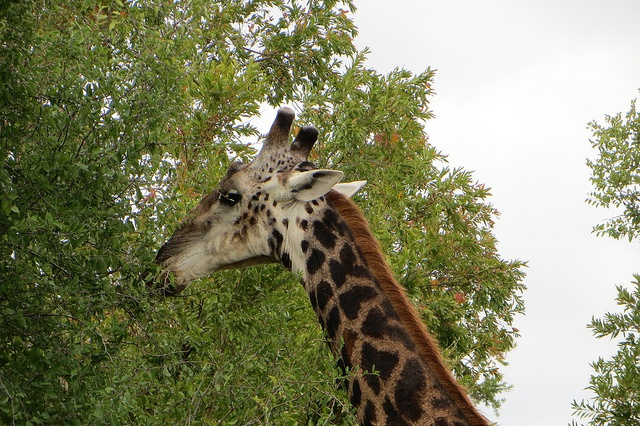Describe the objects in this image and their specific colors. I can see a giraffe in black, olive, maroon, and tan tones in this image. 